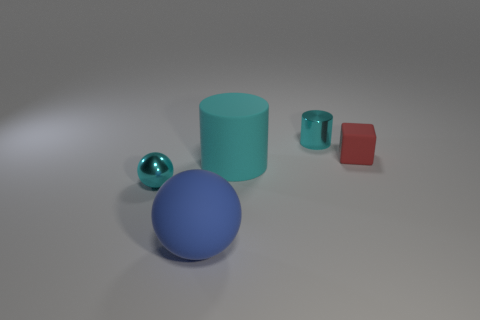Subtract all blue blocks. Subtract all purple spheres. How many blocks are left? 1 Subtract all blue spheres. How many yellow cylinders are left? 0 Add 5 cyans. How many objects exist? 0 Subtract all tiny rubber objects. Subtract all big shiny things. How many objects are left? 4 Add 5 tiny red things. How many tiny red things are left? 6 Add 2 red metal blocks. How many red metal blocks exist? 2 Add 4 small cyan metallic cubes. How many objects exist? 9 Subtract all blue spheres. How many spheres are left? 1 Subtract 0 green cubes. How many objects are left? 5 Subtract all cyan cylinders. How many were subtracted if there are1cyan cylinders left? 1 